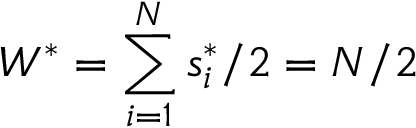<formula> <loc_0><loc_0><loc_500><loc_500>W ^ { * } = \sum _ { i = 1 } ^ { N } s _ { i } ^ { * } / 2 = N / 2</formula> 